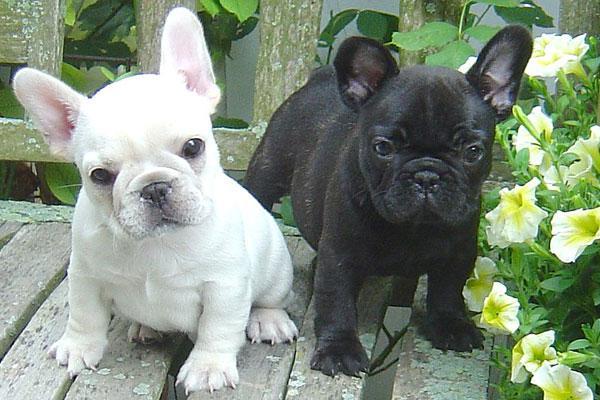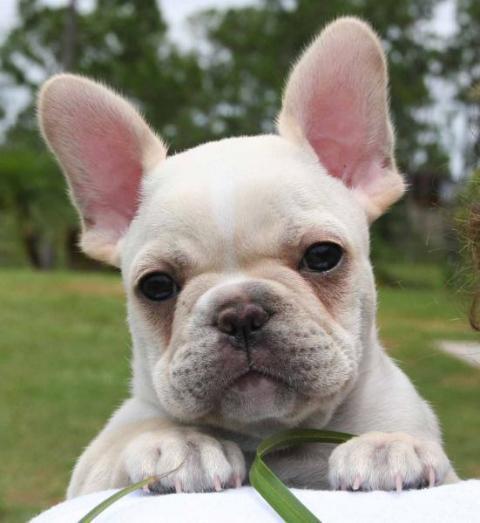The first image is the image on the left, the second image is the image on the right. Assess this claim about the two images: "There are three french bulldogs". Correct or not? Answer yes or no. Yes. The first image is the image on the left, the second image is the image on the right. Considering the images on both sides, is "A total of two blackish dogs are shown." valid? Answer yes or no. No. 